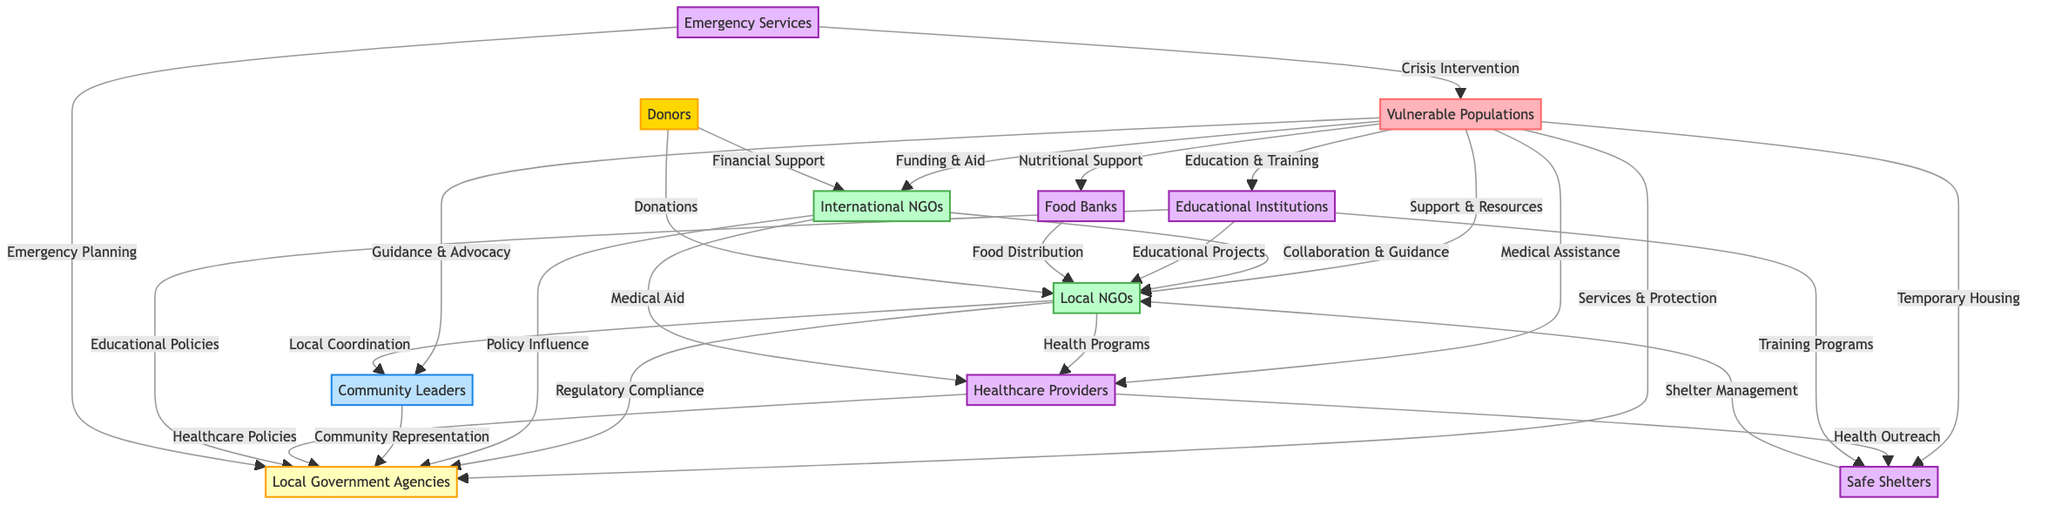What are the total number of nodes in the diagram? By counting each node listed under the "nodes" section of the data, we find 11 nodes total which include all entities involved in the social support network for vulnerable populations.
Answer: 11 What type of support do Local NGOs provide to Vulnerable Populations? From the edge labeled "Support & Resources" connecting Local NGOs to Vulnerable Populations, we see that Local NGOs support vulnerable populations by providing resources and support.
Answer: Support & Resources How many edges are connected to Healthcare Providers? By examining the edges connected to the Healthcare Providers node (node 6), we find there are 4 edges leading to different nodes: Vulnerable Populations, Local Government Agencies, Safe Shelters, and Food Banks.
Answer: 4 Which entity influences policy on Local Government Agencies? Observing the edge labeled "Policy Influence" that connects International NGOs to Local Government Agencies, we see that International NGOs have a role in influencing local policies.
Answer: International NGOs What type of assistance do Emergency Services provide to Vulnerable Populations? The edge labeled "Crisis Intervention" from Emergency Services to Vulnerable Populations indicates that Emergency Services are involved in providing urgent assistance during crises.
Answer: Crisis Intervention How many direct connections does Local Government Agencies have? By reviewing the edges connected to Local Government Agencies (node 5), we find it has 6 direct connections from different entities, including Local NGOs, International NGOs, Community Leaders, Healthcare Providers, and Emergency Services.
Answer: 6 Which entity is primarily responsible for food distribution in the network? The edge labeled "Food Distribution" connects Food Banks to Local NGOs, signifying that Food Banks are primarily responsible for distributing food within the network.
Answer: Food Banks Which two entities collaborate on medical aid according to the diagram? There are two edges related to medical assistance: "Health Programs" from Local NGOs to Healthcare Providers and "Medical Aid" from International NGOs to Healthcare Providers, showing collaboration on medical aid from both Local and International NGOs to the Healthcare Providers.
Answer: Local NGOs and International NGOs What role do Community Leaders play in supporting Vulnerable Populations? The edge labeled "Guidance & Advocacy" connects Community Leaders to Vulnerable Populations, showing they provide guidance and advocate for the needs of vulnerable populations.
Answer: Guidance & Advocacy 